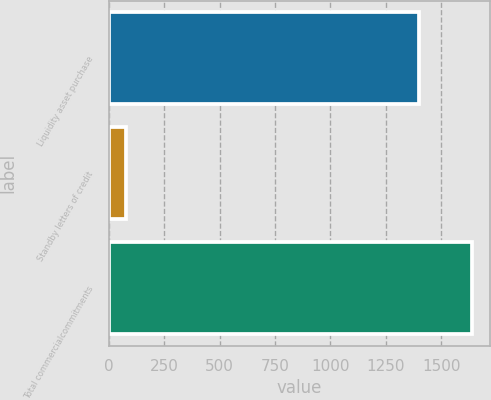<chart> <loc_0><loc_0><loc_500><loc_500><bar_chart><fcel>Liquidity asset purchase<fcel>Standby letters of credit<fcel>Total commercialcommitments<nl><fcel>1401<fcel>78<fcel>1640<nl></chart> 